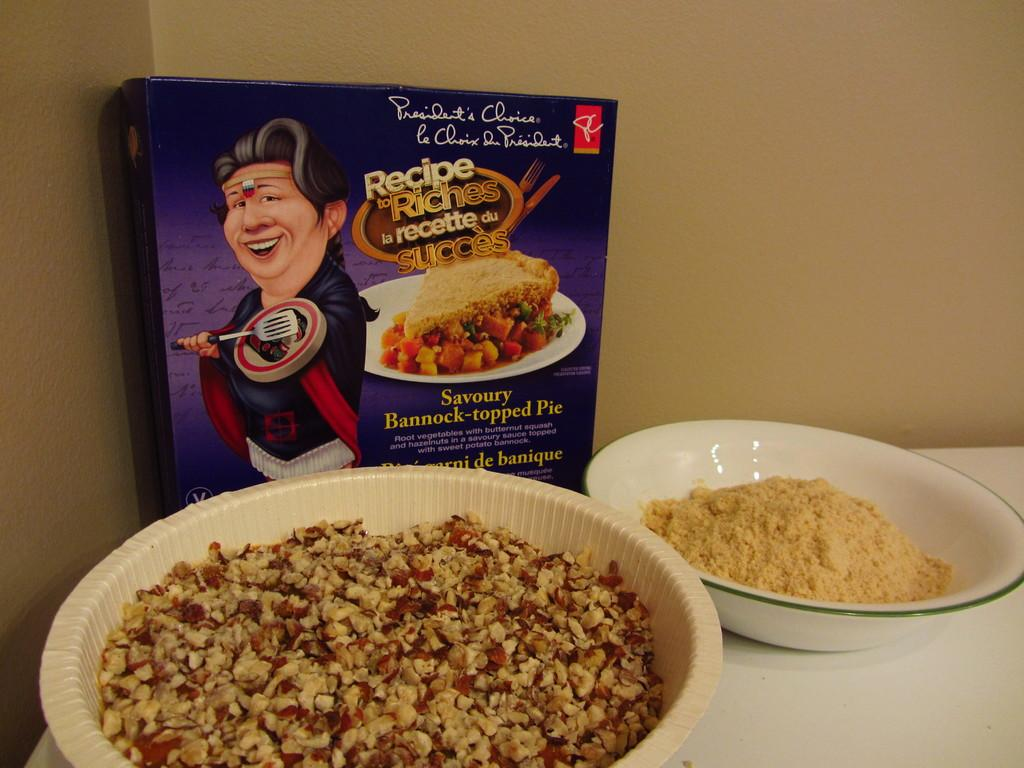What type of furniture is in the image? There is a table in the image. What is placed on the table? Food items are present in bowls on the table. Can you describe any other objects in the image? There is a box visible in the image. What time does the clock show in the image? There is no clock present in the image. How many ladybugs are crawling on the food items in the image? There are no ladybugs present in the image. 